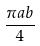Convert formula to latex. <formula><loc_0><loc_0><loc_500><loc_500>\frac { \pi a b } { 4 }</formula> 